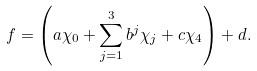Convert formula to latex. <formula><loc_0><loc_0><loc_500><loc_500>f = \left ( a \chi _ { 0 } + \sum _ { j = 1 } ^ { 3 } b ^ { j } \chi _ { j } + c \chi _ { 4 } \right ) + d .</formula> 